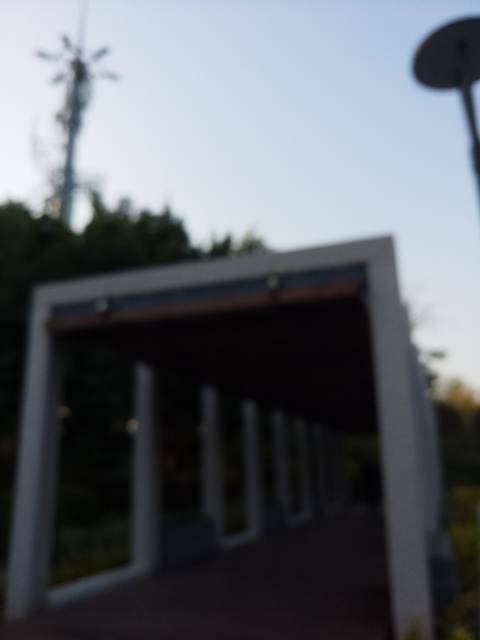Could you describe what this image might depict if it were in focus? If the image were in focus, it appears to show an architectural structure, possibly a modern pergola or pavilion with a flat top and supporting columns. The background might include trees and perhaps an antenna in the distance, suggesting that this is an outdoor setting, possibly a park or public space. 